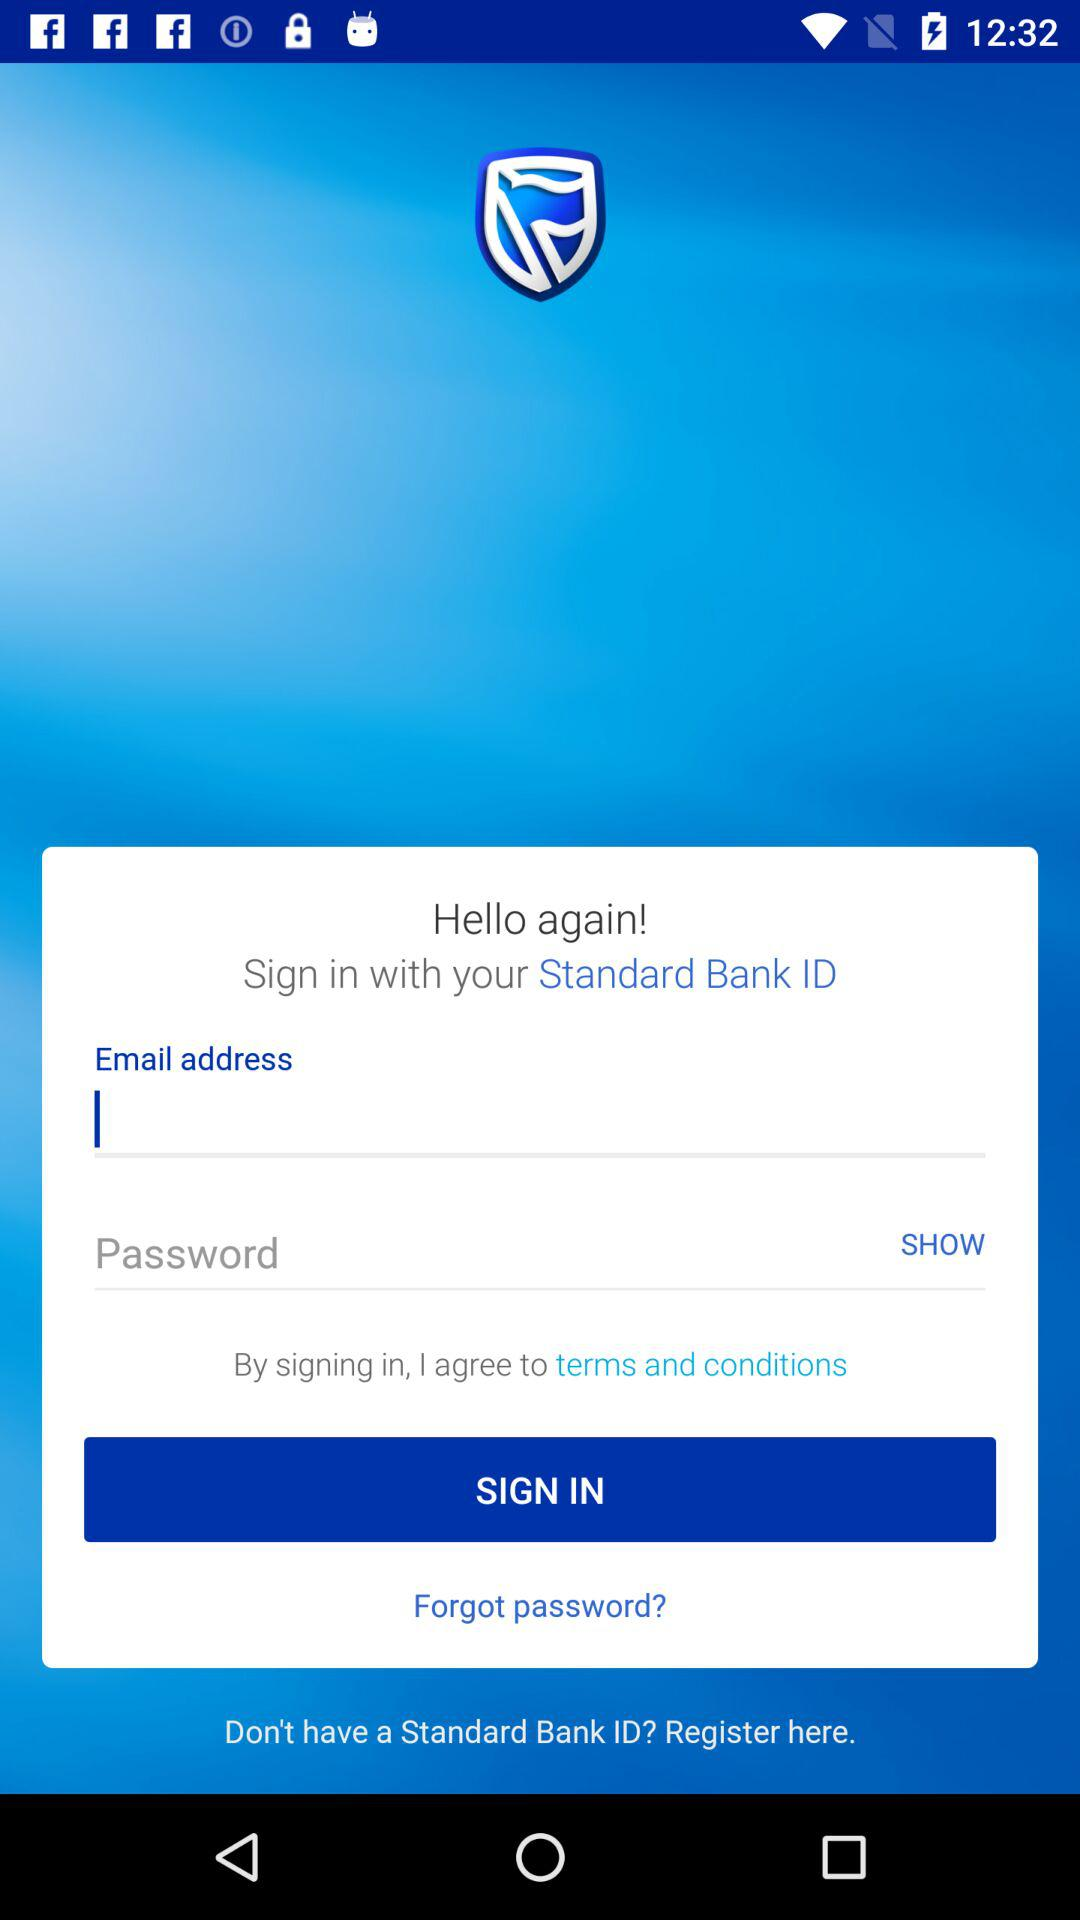With what ID can the user log in? The user can log in with a Standard Bank ID. 